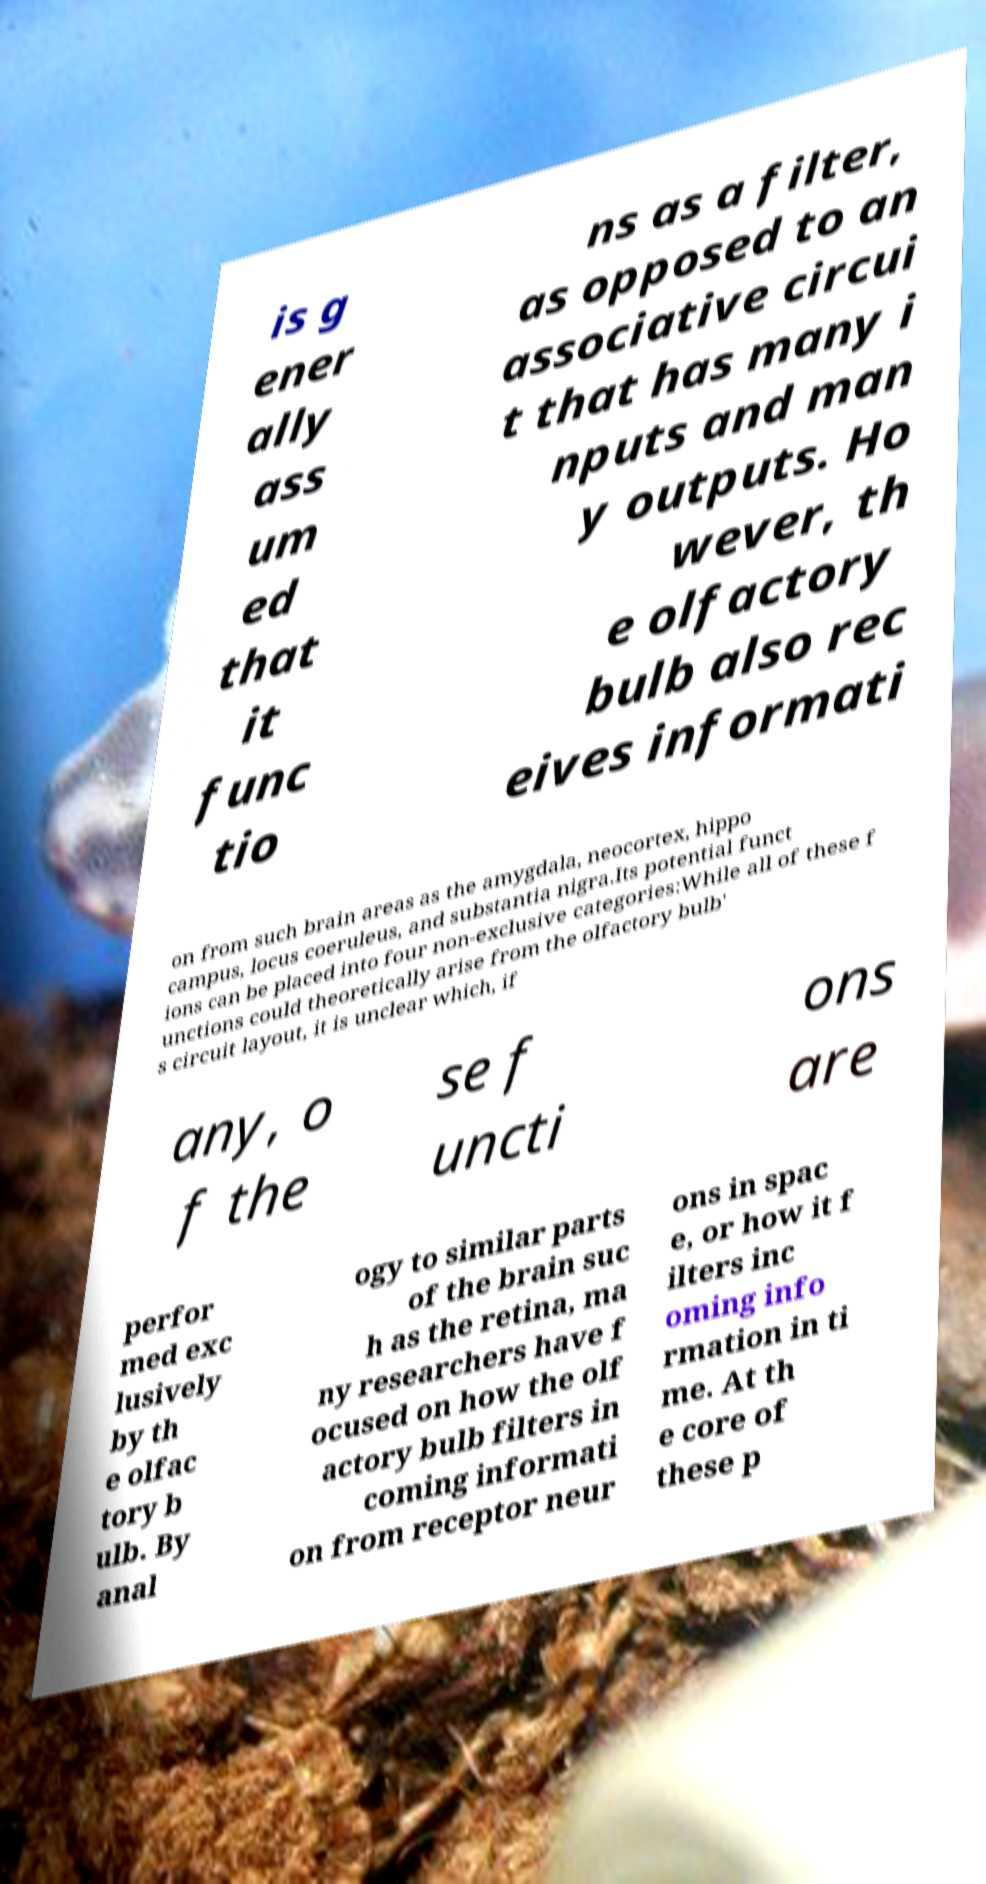Could you assist in decoding the text presented in this image and type it out clearly? is g ener ally ass um ed that it func tio ns as a filter, as opposed to an associative circui t that has many i nputs and man y outputs. Ho wever, th e olfactory bulb also rec eives informati on from such brain areas as the amygdala, neocortex, hippo campus, locus coeruleus, and substantia nigra.Its potential funct ions can be placed into four non-exclusive categories:While all of these f unctions could theoretically arise from the olfactory bulb' s circuit layout, it is unclear which, if any, o f the se f uncti ons are perfor med exc lusively by th e olfac tory b ulb. By anal ogy to similar parts of the brain suc h as the retina, ma ny researchers have f ocused on how the olf actory bulb filters in coming informati on from receptor neur ons in spac e, or how it f ilters inc oming info rmation in ti me. At th e core of these p 